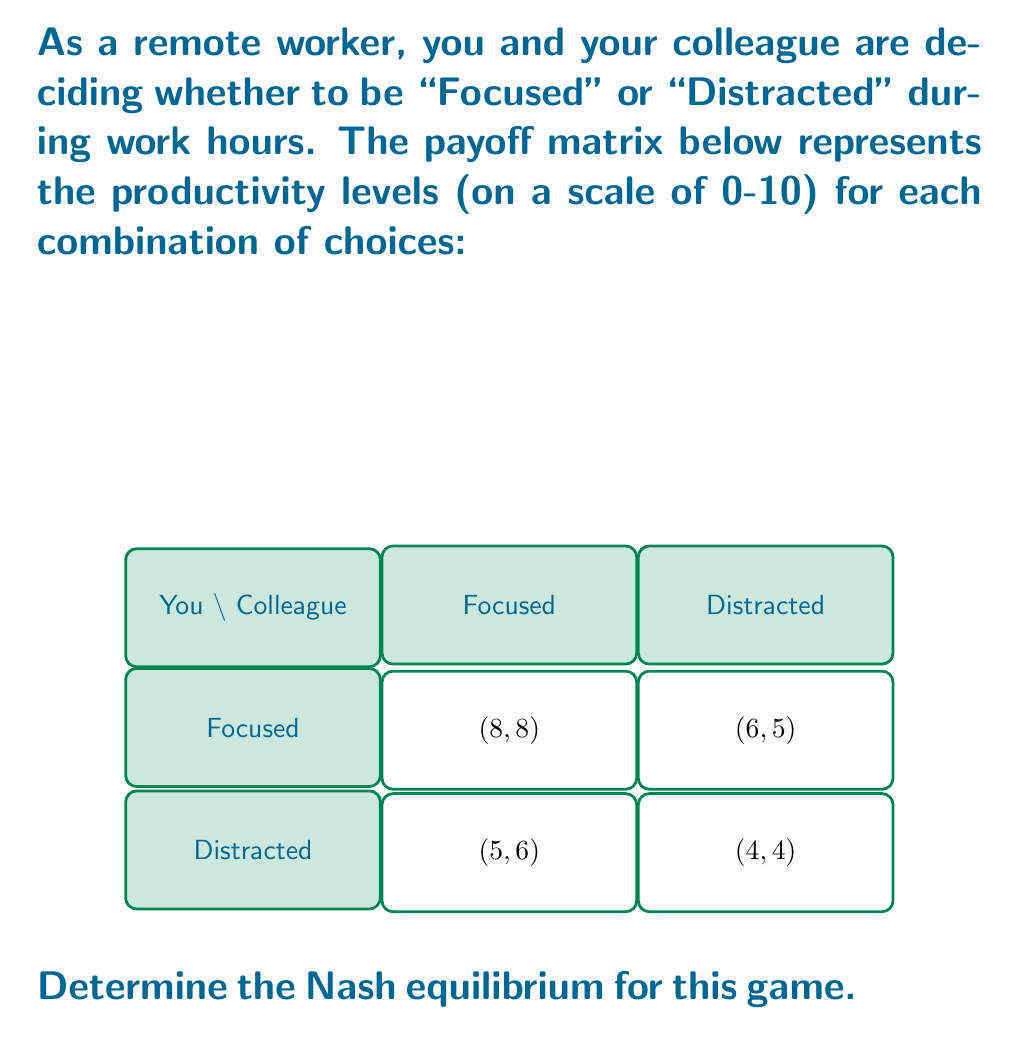Can you answer this question? To find the Nash equilibrium, we need to analyze each player's best response to the other player's strategy:

1. If your colleague chooses "Focused":
   - Your payoff for "Focused": 8
   - Your payoff for "Distracted": 6
   Your best response is "Focused"

2. If your colleague chooses "Distracted":
   - Your payoff for "Focused": 5
   - Your payoff for "Distracted": 4
   Your best response is "Focused"

3. If you choose "Focused":
   - Colleague's payoff for "Focused": 8
   - Colleague's payoff for "Distracted": 5
   Colleague's best response is "Focused"

4. If you choose "Distracted":
   - Colleague's payoff for "Focused": 6
   - Colleague's payoff for "Distracted": 4
   Colleague's best response is "Focused"

In this game, regardless of what the other player does, both players always have "Focused" as their best response. This means that (Focused, Focused) is the only Nash equilibrium.

The Nash equilibrium occurs when both players choose "Focused", resulting in a payoff of (8, 8).

This equilibrium represents a situation where both remote workers maintain focus during work hours, leading to maximum productivity for both.
Answer: (Focused, Focused) with payoffs (8, 8) 